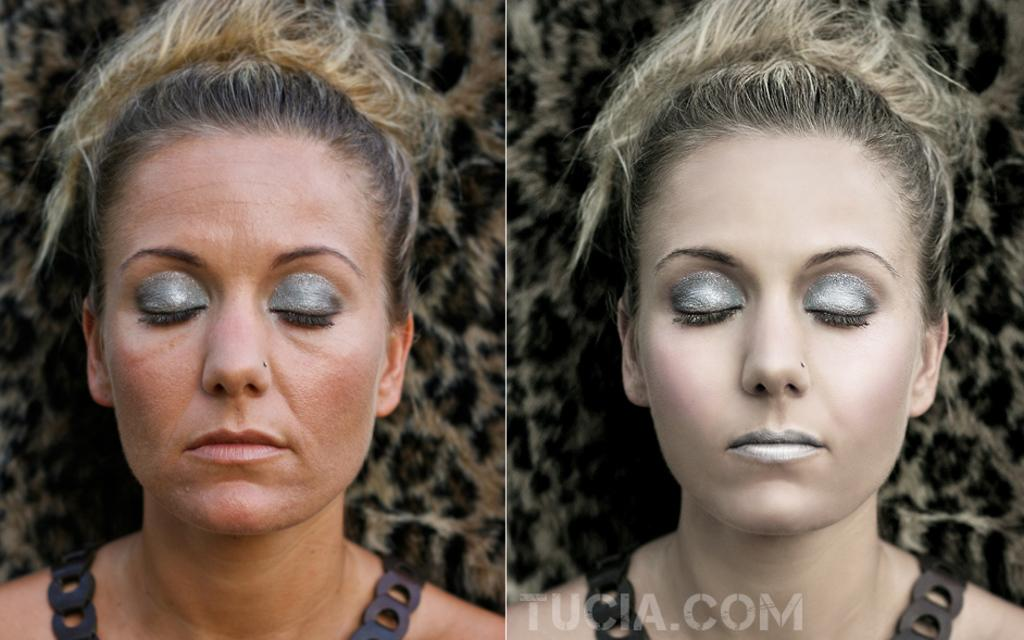What type of image is shown in the picture? The image is a collage. How many women's pictures are included in the collage? There are two women's pictures in the collage. Are there any differences between the two women's pictures? Yes, one of the women's pictures has text. What type of plants can be seen growing out of the women's noses in the image? There are no plants or noses visible in the image, as it is a collage of women's pictures with text. 